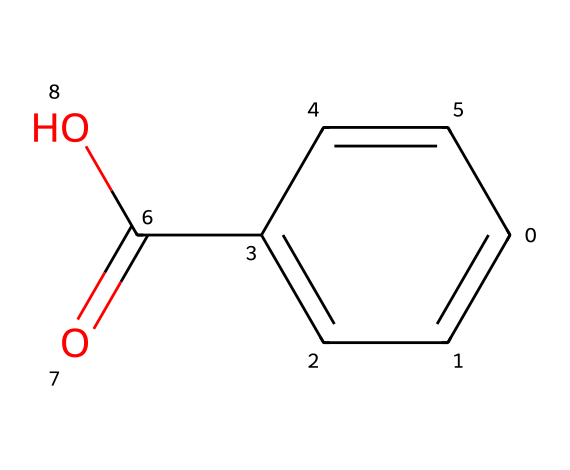What is the molecular formula of benzoic acid? To find the molecular formula, you can count the number of each type of atom in the structure. In this case, there are 7 carbon atoms (C), 6 hydrogen atoms (H), and 2 oxygen atoms (O). Therefore, the molecular formula is C7H6O2.
Answer: C7H6O2 How many double bonds are present in benzoic acid? By analyzing the structure, you can identify the bonds. There are two double bonds: one between the carbon atoms in the aromatic ring and one between the carbon and oxygen in the carboxylic acid group.
Answer: 2 What type of functional group does benzoic acid contain? The carboxylic acid group (-COOH) is present in the structure of benzoic acid, characterized by a carbon atom double-bonded to one oxygen and single-bonded to another oxygen that is further bonded to hydrogen.
Answer: carboxylic acid What is the significance of the aromatic ring in benzoic acid? The aromatic ring imparts stability and contributes to the chemical's properties, including its ability to serve as a preservative. Aromatic compounds often have distinctive flavors and are less likely to spoil.
Answer: preservative How many hydrogen atoms are attached to the benzene ring in benzoic acid? There are four hydrogen atoms attached to the benzene ring. You can deduce this by observing the structure of the ring and noting that one hydrogen is replaced by the carboxylic group.
Answer: 4 